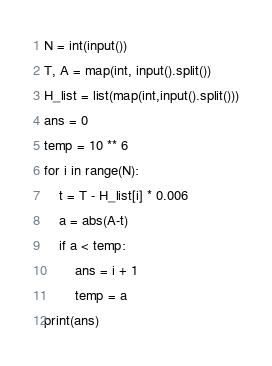<code> <loc_0><loc_0><loc_500><loc_500><_Python_>N = int(input())
T, A = map(int, input().split())
H_list = list(map(int,input().split()))
ans = 0
temp = 10 ** 6
for i in range(N):
    t = T - H_list[i] * 0.006
    a = abs(A-t)
    if a < temp:
        ans = i + 1
        temp = a
print(ans)
</code> 